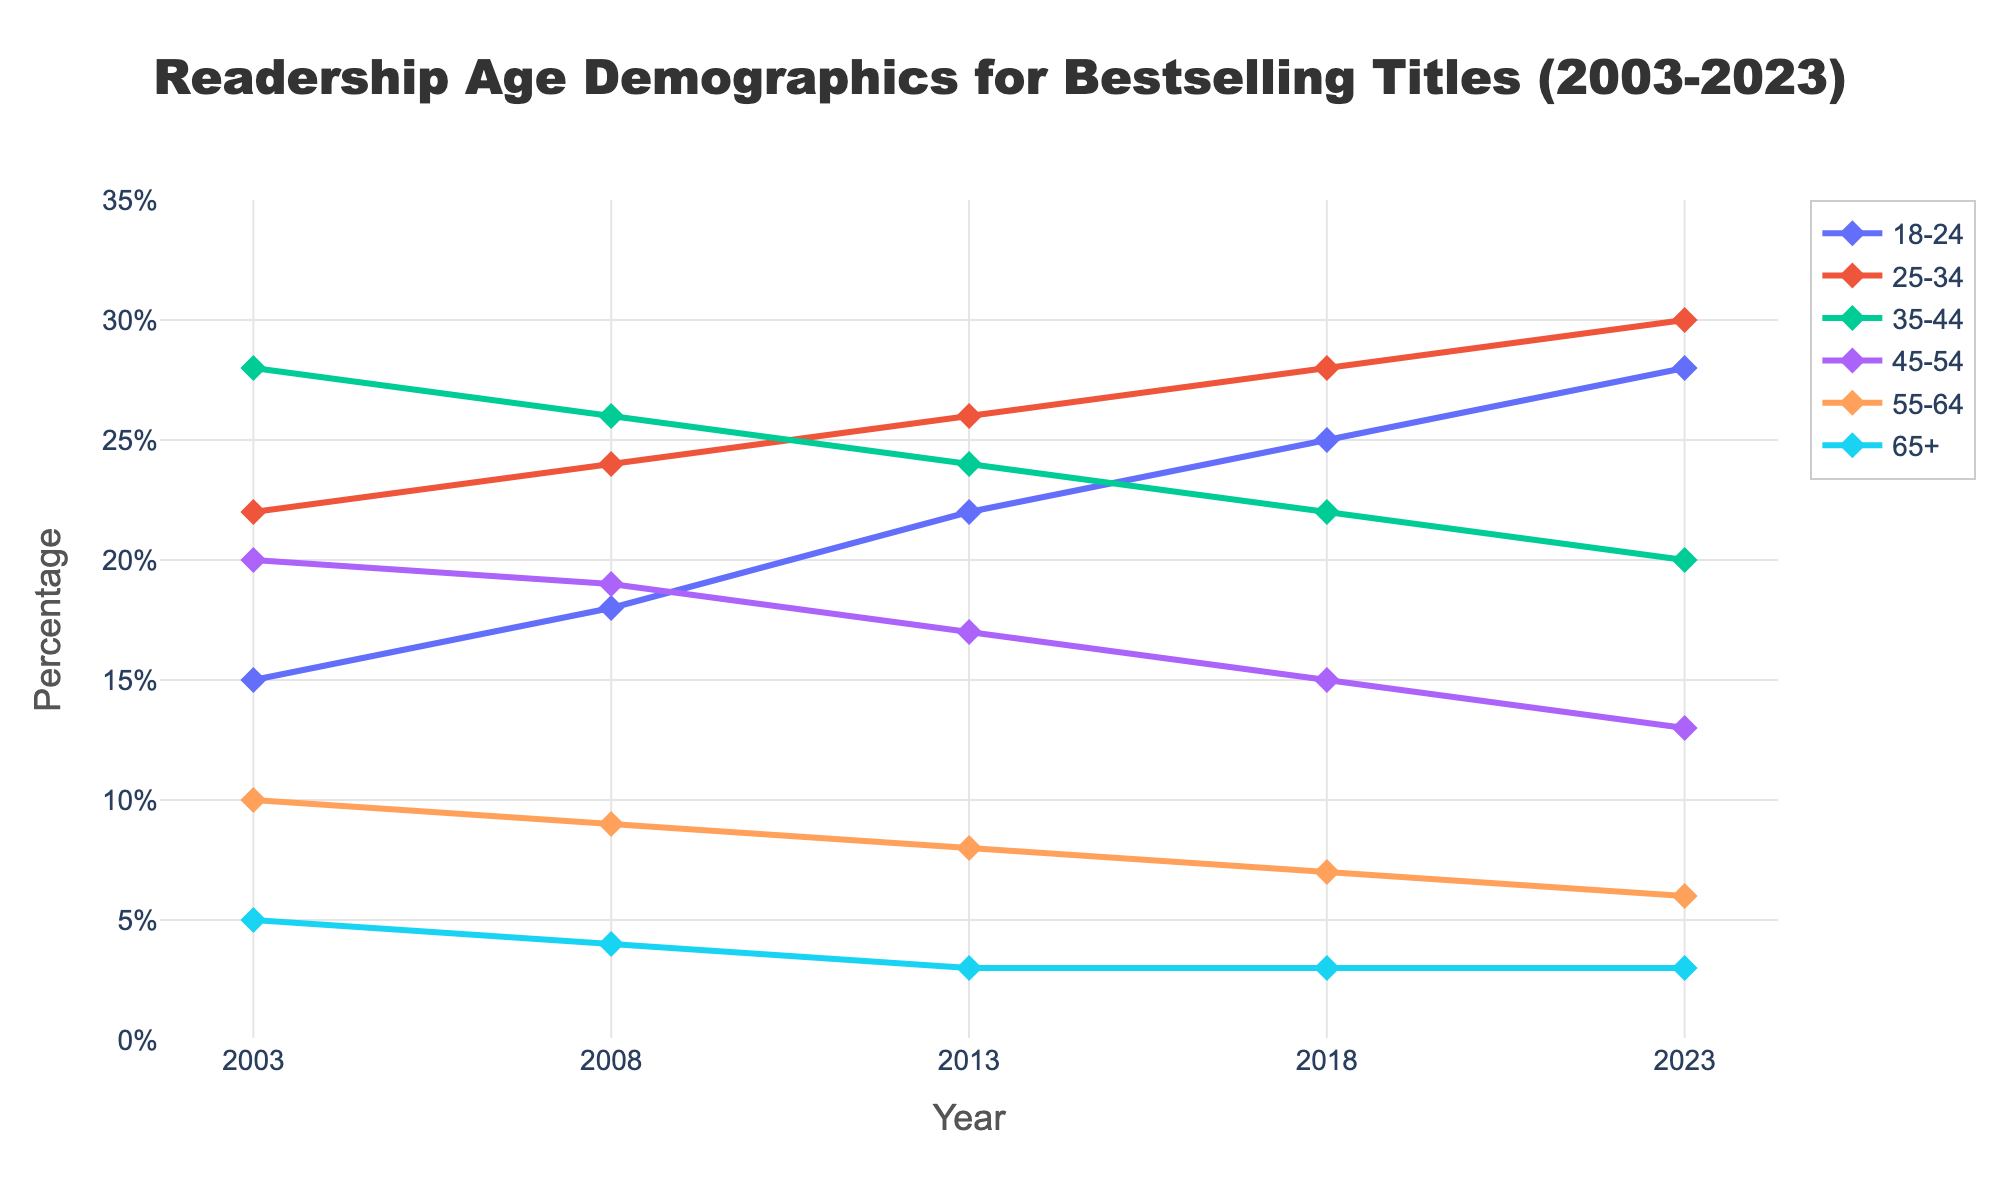Which age group experienced the most significant increase in readership percentage from 2003 to 2023? By examining the lines representing each age group, the group with the steepest upward slope will have the largest increase. The 18-24 age group increased from 15% in 2003 to 28% in 2023. That's a change of 28% - 15% = 13%.
Answer: 18-24 Which age group showed a decline in readership percentage over the years? We need to observe the lines trending downward over the years. The 35-44 age group declined from 28% in 2003 to 20% in 2023. Similarly, the 45-54, 55-64, and 65+ age groups also declined.
Answer: 35-44, 45-54, 55-64, 65+ At which year did the 18-24 age group exceed 20% readership? Trace the line associated with the 18-24 age group and find the year when it first exceeds the 20% mark. The 18-24 age group reaches above 20% readership in the year 2013.
Answer: 2013 What is the combined readership percentage of the 25-34 and 35-44 age groups in 2023? Find the values for both age groups in 2023. The 25-34 group is 30% and the 35-44 group is 20%. Sum them up: 30% + 20% = 50%.
Answer: 50% Which age group had the highest readership percentage in 2003? Look at the values for each age group in 2003. The 35-44 age group had the highest percentage at 28%.
Answer: 35-44 What trend do you observe for the 65+ age group over the years? Observe the trend line for the 65+ age group. It starts at 5% in 2003 and declines to 3% in 2008, remaining constant afterward until 2023.
Answer: Declined initially, then stable How did the 45-54 age group change compared to the 55-64 age group from 2003 to 2023? Compare the trend lines for both age groups. The 45-54 group declined from 20% to 13%, while the 55-64 group declined from 10% to 6%. The 45-54 group had a more significant numerical decline.
Answer: 45-54 group declined more Which year showed the smallest difference in readership percentage between the 18-24 and 25-34 age groups? Calculate the differences between the two groups' percentages for each year. The smallest difference is in 2023, where the 18-24 group is at 28% and the 25-34 group is at 30%. The difference is 2%.
Answer: 2023 In what year did the 35-44 age group see a crossover with the 25-34 age group? Identify the intersection of lines between the 35-44 and 25-34 age groups. The crossover occurs in 2008, where both groups are at 24%.
Answer: 2008 